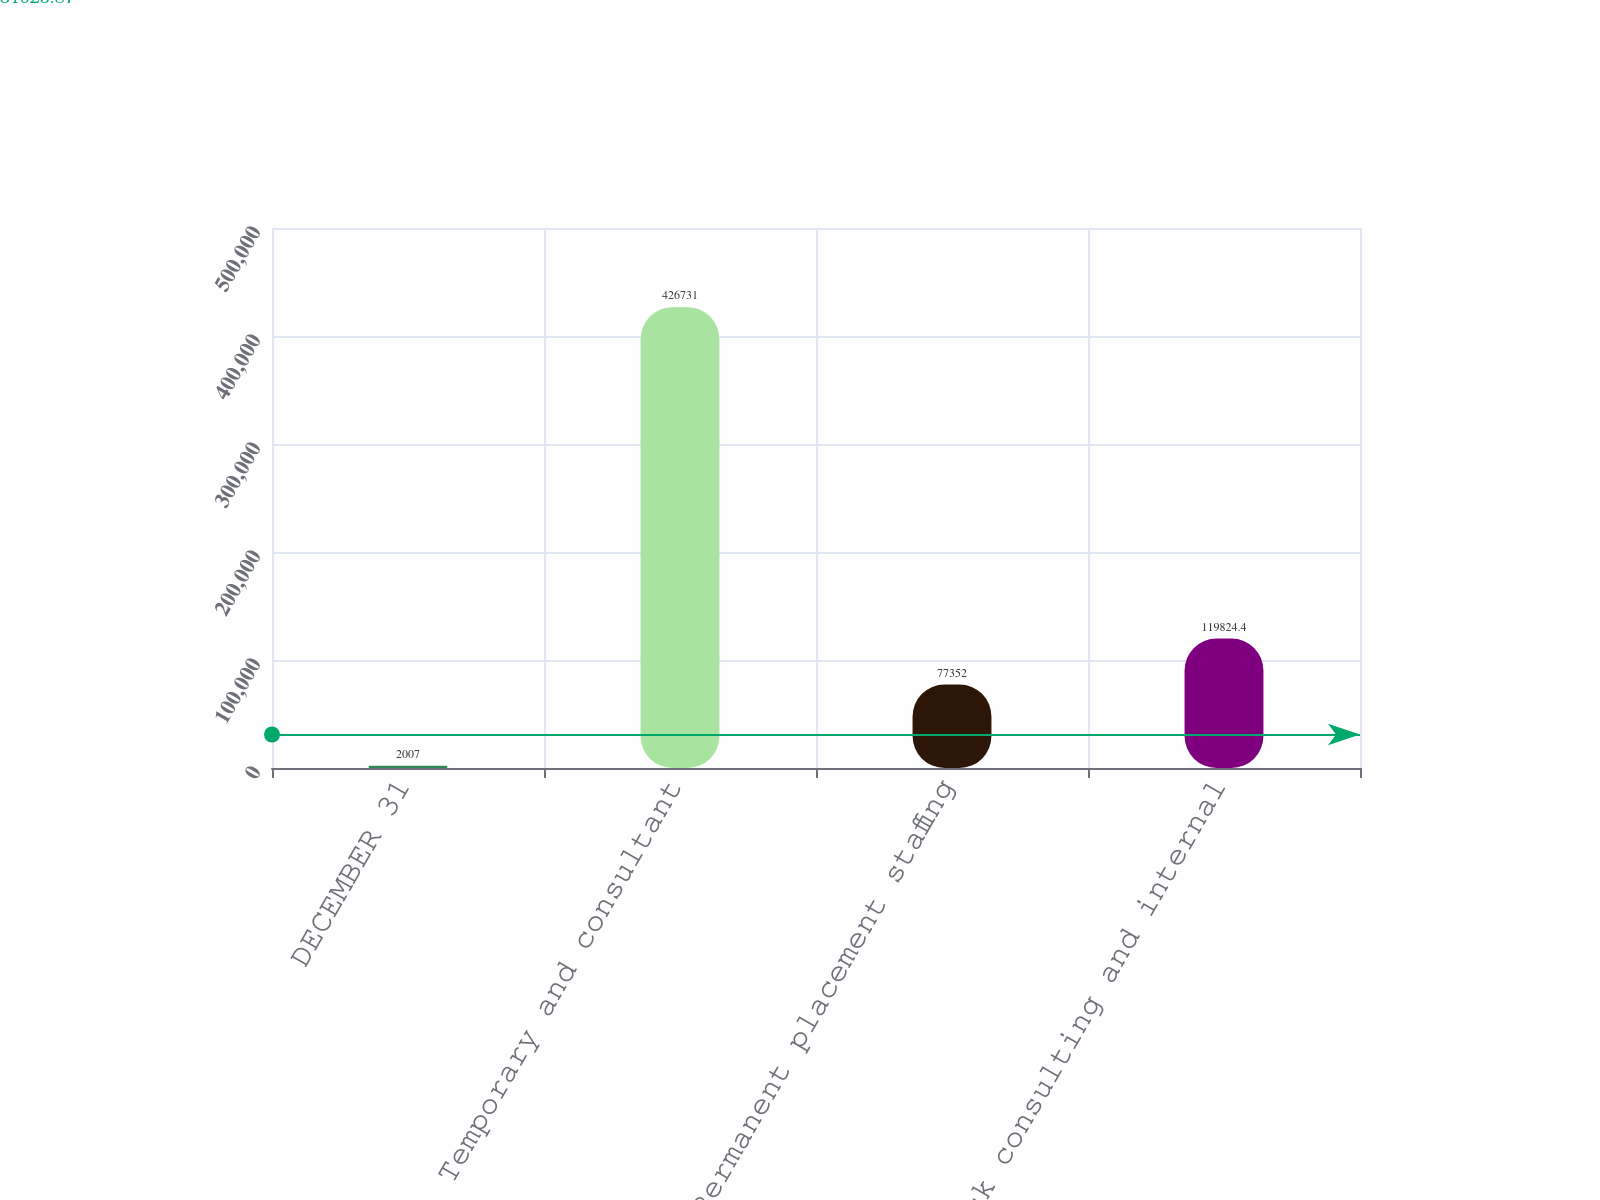Convert chart. <chart><loc_0><loc_0><loc_500><loc_500><bar_chart><fcel>DECEMBER 31<fcel>Temporary and consultant<fcel>Permanent placement staffing<fcel>Risk consulting and internal<nl><fcel>2007<fcel>426731<fcel>77352<fcel>119824<nl></chart> 